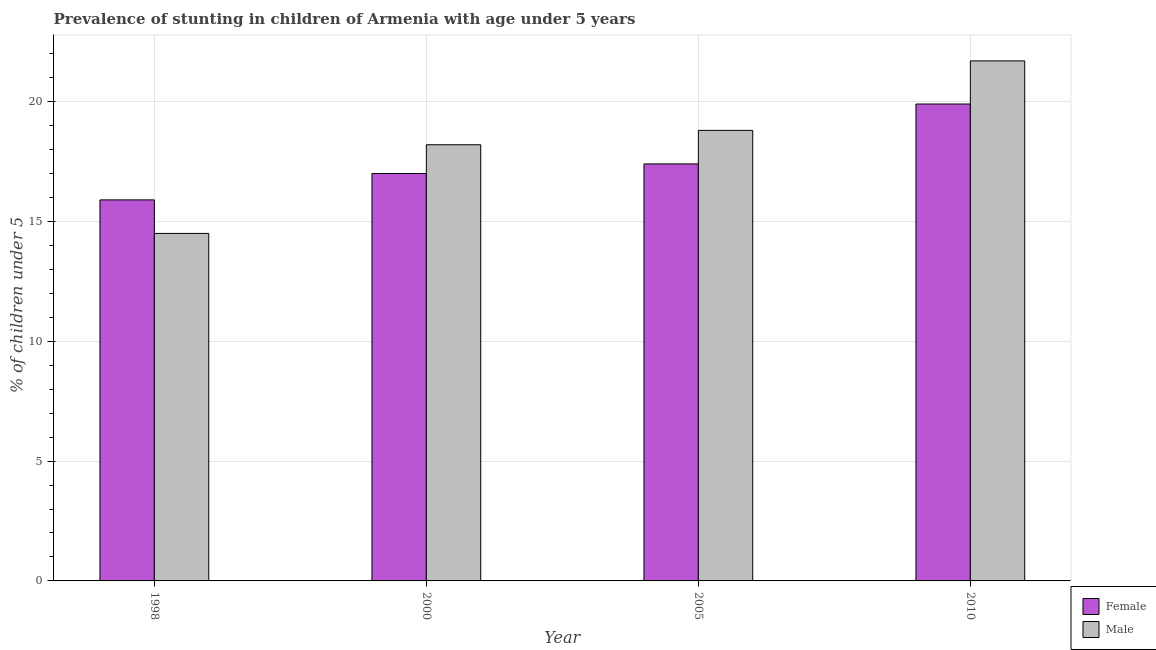How many groups of bars are there?
Provide a short and direct response. 4. Are the number of bars per tick equal to the number of legend labels?
Give a very brief answer. Yes. How many bars are there on the 1st tick from the left?
Provide a succinct answer. 2. What is the percentage of stunted female children in 1998?
Offer a terse response. 15.9. Across all years, what is the maximum percentage of stunted male children?
Provide a succinct answer. 21.7. In which year was the percentage of stunted female children maximum?
Provide a succinct answer. 2010. In which year was the percentage of stunted male children minimum?
Make the answer very short. 1998. What is the total percentage of stunted male children in the graph?
Your answer should be very brief. 73.2. What is the difference between the percentage of stunted female children in 2000 and that in 2005?
Your answer should be very brief. -0.4. What is the difference between the percentage of stunted male children in 2005 and the percentage of stunted female children in 2010?
Ensure brevity in your answer.  -2.9. What is the average percentage of stunted male children per year?
Ensure brevity in your answer.  18.3. What is the ratio of the percentage of stunted male children in 2000 to that in 2010?
Offer a very short reply. 0.84. What is the difference between the highest and the second highest percentage of stunted male children?
Your answer should be compact. 2.9. What is the difference between the highest and the lowest percentage of stunted male children?
Your answer should be very brief. 7.2. What does the 1st bar from the right in 1998 represents?
Provide a short and direct response. Male. How many years are there in the graph?
Give a very brief answer. 4. What is the difference between two consecutive major ticks on the Y-axis?
Offer a very short reply. 5. Does the graph contain grids?
Offer a terse response. Yes. Where does the legend appear in the graph?
Ensure brevity in your answer.  Bottom right. What is the title of the graph?
Keep it short and to the point. Prevalence of stunting in children of Armenia with age under 5 years. What is the label or title of the X-axis?
Offer a very short reply. Year. What is the label or title of the Y-axis?
Your answer should be compact.  % of children under 5. What is the  % of children under 5 in Female in 1998?
Keep it short and to the point. 15.9. What is the  % of children under 5 of Male in 1998?
Make the answer very short. 14.5. What is the  % of children under 5 in Male in 2000?
Offer a very short reply. 18.2. What is the  % of children under 5 in Female in 2005?
Your answer should be very brief. 17.4. What is the  % of children under 5 of Male in 2005?
Give a very brief answer. 18.8. What is the  % of children under 5 of Female in 2010?
Ensure brevity in your answer.  19.9. What is the  % of children under 5 in Male in 2010?
Offer a terse response. 21.7. Across all years, what is the maximum  % of children under 5 of Female?
Your answer should be compact. 19.9. Across all years, what is the maximum  % of children under 5 of Male?
Offer a terse response. 21.7. Across all years, what is the minimum  % of children under 5 in Female?
Your answer should be very brief. 15.9. What is the total  % of children under 5 in Female in the graph?
Make the answer very short. 70.2. What is the total  % of children under 5 in Male in the graph?
Offer a terse response. 73.2. What is the difference between the  % of children under 5 in Male in 1998 and that in 2000?
Your response must be concise. -3.7. What is the difference between the  % of children under 5 of Female in 1998 and that in 2005?
Ensure brevity in your answer.  -1.5. What is the difference between the  % of children under 5 in Female in 1998 and that in 2010?
Your answer should be very brief. -4. What is the difference between the  % of children under 5 in Male in 2000 and that in 2005?
Offer a terse response. -0.6. What is the difference between the  % of children under 5 in Female in 2005 and that in 2010?
Make the answer very short. -2.5. What is the difference between the  % of children under 5 in Male in 2005 and that in 2010?
Ensure brevity in your answer.  -2.9. What is the difference between the  % of children under 5 of Female in 1998 and the  % of children under 5 of Male in 2005?
Keep it short and to the point. -2.9. What is the difference between the  % of children under 5 in Female in 1998 and the  % of children under 5 in Male in 2010?
Make the answer very short. -5.8. What is the difference between the  % of children under 5 of Female in 2000 and the  % of children under 5 of Male in 2005?
Give a very brief answer. -1.8. What is the difference between the  % of children under 5 in Female in 2000 and the  % of children under 5 in Male in 2010?
Offer a terse response. -4.7. What is the difference between the  % of children under 5 in Female in 2005 and the  % of children under 5 in Male in 2010?
Keep it short and to the point. -4.3. What is the average  % of children under 5 of Female per year?
Your response must be concise. 17.55. What is the average  % of children under 5 of Male per year?
Your answer should be very brief. 18.3. In the year 2010, what is the difference between the  % of children under 5 in Female and  % of children under 5 in Male?
Provide a succinct answer. -1.8. What is the ratio of the  % of children under 5 of Female in 1998 to that in 2000?
Your answer should be compact. 0.94. What is the ratio of the  % of children under 5 of Male in 1998 to that in 2000?
Give a very brief answer. 0.8. What is the ratio of the  % of children under 5 of Female in 1998 to that in 2005?
Your answer should be compact. 0.91. What is the ratio of the  % of children under 5 in Male in 1998 to that in 2005?
Give a very brief answer. 0.77. What is the ratio of the  % of children under 5 in Female in 1998 to that in 2010?
Ensure brevity in your answer.  0.8. What is the ratio of the  % of children under 5 in Male in 1998 to that in 2010?
Keep it short and to the point. 0.67. What is the ratio of the  % of children under 5 of Male in 2000 to that in 2005?
Keep it short and to the point. 0.97. What is the ratio of the  % of children under 5 in Female in 2000 to that in 2010?
Provide a succinct answer. 0.85. What is the ratio of the  % of children under 5 of Male in 2000 to that in 2010?
Your answer should be very brief. 0.84. What is the ratio of the  % of children under 5 of Female in 2005 to that in 2010?
Your answer should be compact. 0.87. What is the ratio of the  % of children under 5 of Male in 2005 to that in 2010?
Your response must be concise. 0.87. What is the difference between the highest and the second highest  % of children under 5 in Female?
Your answer should be very brief. 2.5. What is the difference between the highest and the second highest  % of children under 5 of Male?
Give a very brief answer. 2.9. What is the difference between the highest and the lowest  % of children under 5 of Male?
Provide a short and direct response. 7.2. 